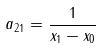<formula> <loc_0><loc_0><loc_500><loc_500>a _ { 2 1 } = \frac { 1 } { x _ { 1 } - x _ { 0 } }</formula> 